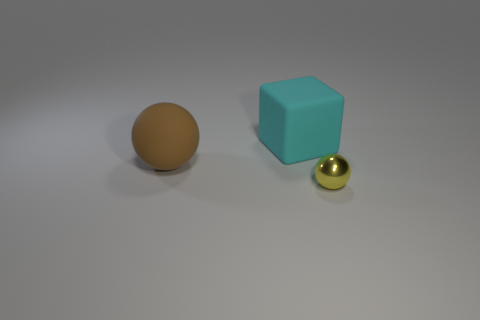Add 2 big red balls. How many objects exist? 5 Subtract all blocks. How many objects are left? 2 Subtract 0 brown blocks. How many objects are left? 3 Subtract all big green cylinders. Subtract all balls. How many objects are left? 1 Add 1 large brown spheres. How many large brown spheres are left? 2 Add 3 matte objects. How many matte objects exist? 5 